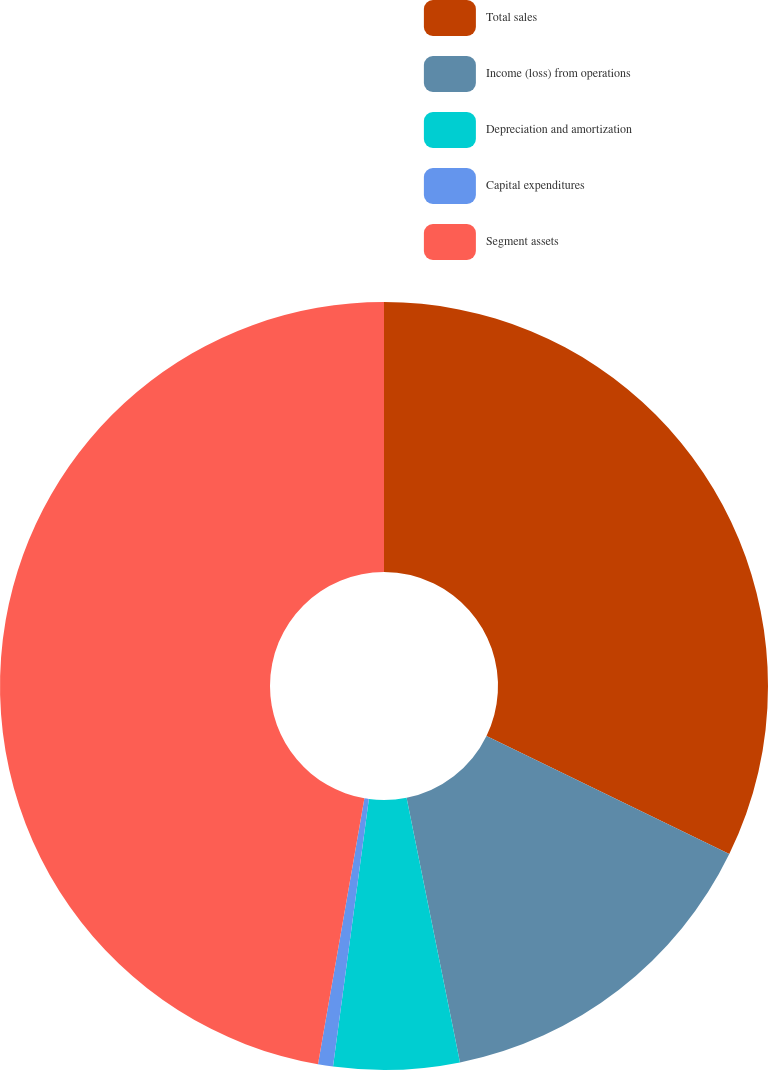Convert chart. <chart><loc_0><loc_0><loc_500><loc_500><pie_chart><fcel>Total sales<fcel>Income (loss) from operations<fcel>Depreciation and amortization<fcel>Capital expenditures<fcel>Segment assets<nl><fcel>32.21%<fcel>14.62%<fcel>5.29%<fcel>0.63%<fcel>47.25%<nl></chart> 